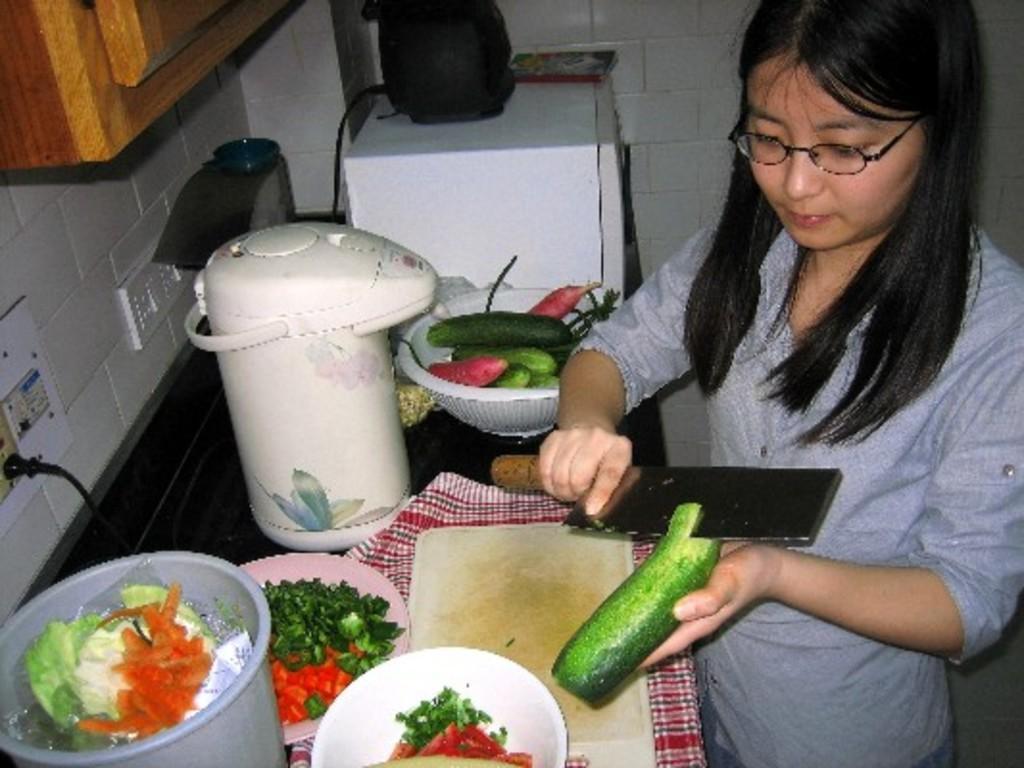Please provide a concise description of this image. In this picture there is a woman who is cutting the cucumber with knife. She is standing near to the kitchen platform. On the platform I can see the oven, grinder machine, basket, cucumber, tomato pieces, bowl, plate, vegetable pieces, bucket and other objects. In the top left corner there is a cupboard. On the left I can see some cables are connected to the socket. 